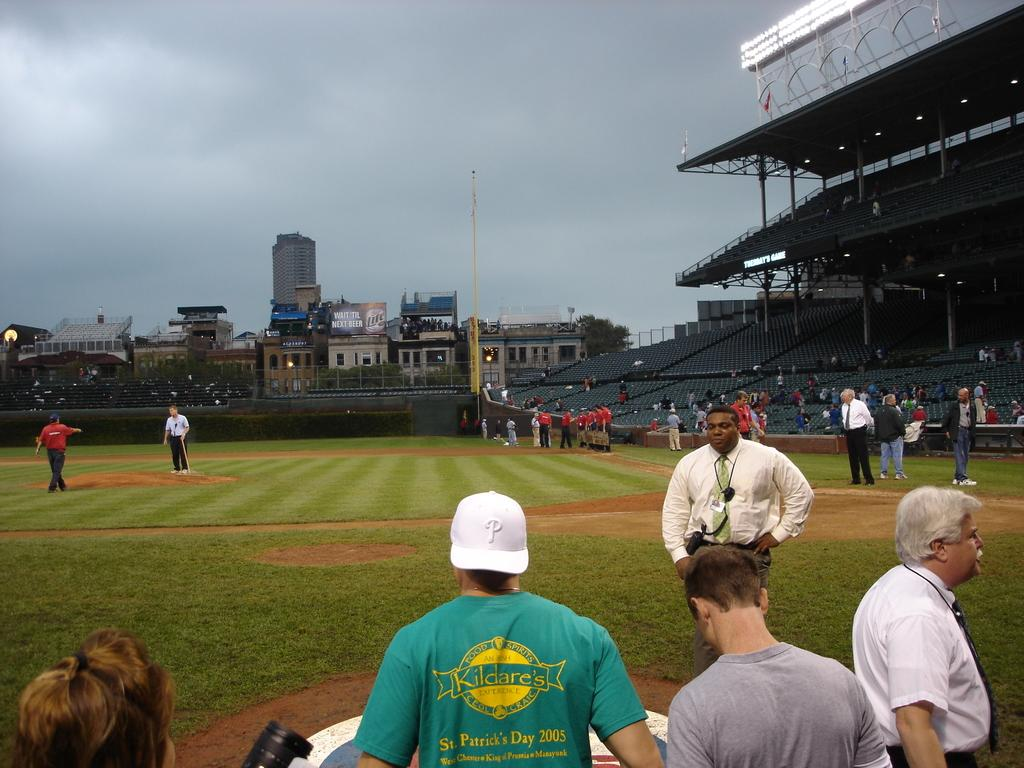Provide a one-sentence caption for the provided image. a baseball field with spectators around the perimeter including one in a green KILDARE's t-shirt. 